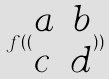Convert formula to latex. <formula><loc_0><loc_0><loc_500><loc_500>f ( ( \begin{matrix} a & b \\ c & d \end{matrix} ) )</formula> 